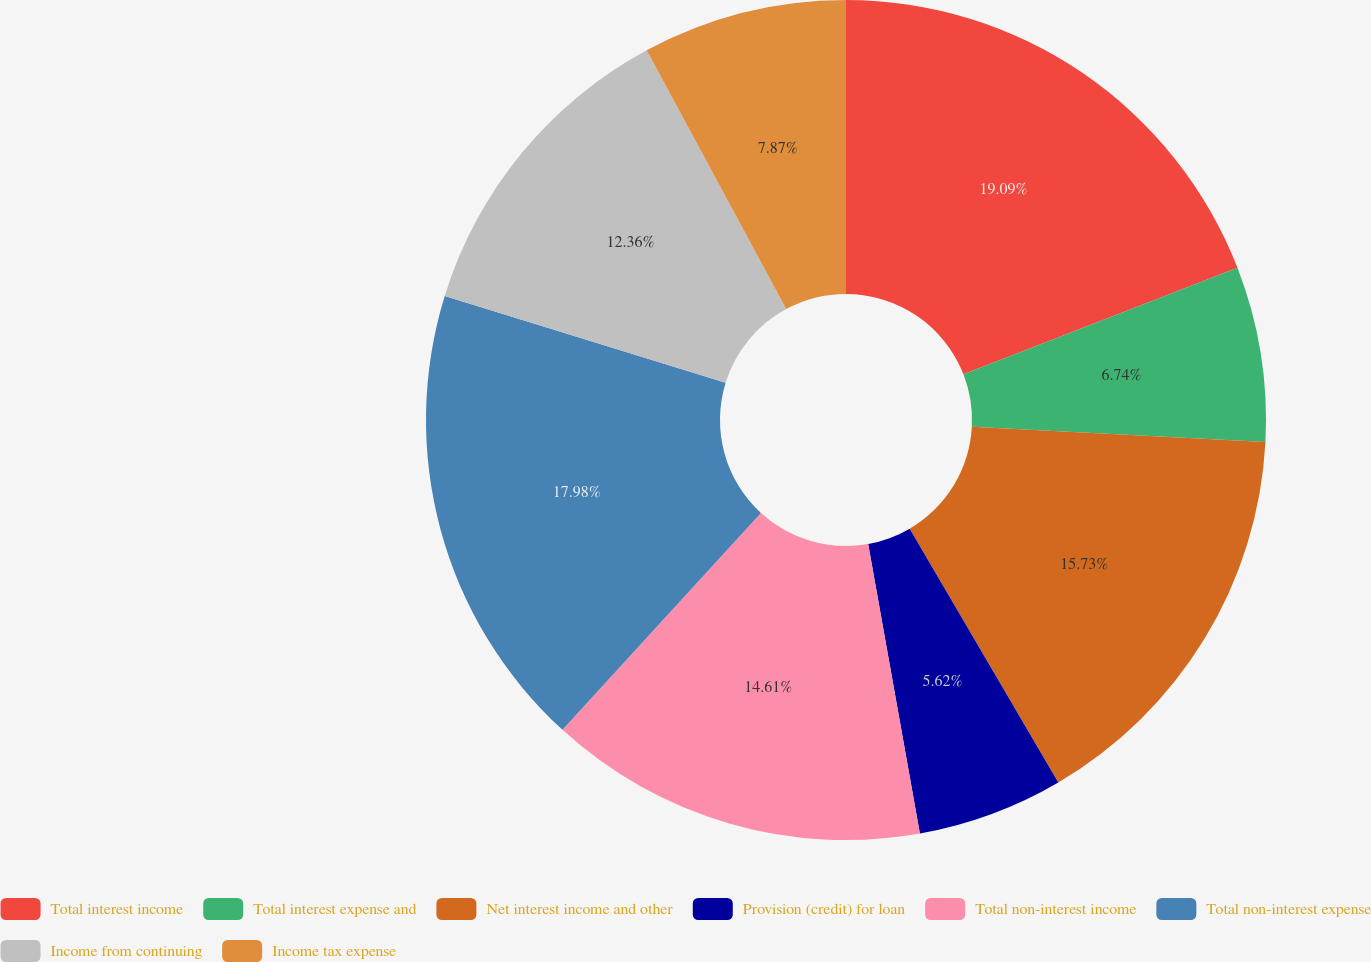Convert chart to OTSL. <chart><loc_0><loc_0><loc_500><loc_500><pie_chart><fcel>Total interest income<fcel>Total interest expense and<fcel>Net interest income and other<fcel>Provision (credit) for loan<fcel>Total non-interest income<fcel>Total non-interest expense<fcel>Income from continuing<fcel>Income tax expense<nl><fcel>19.1%<fcel>6.74%<fcel>15.73%<fcel>5.62%<fcel>14.61%<fcel>17.98%<fcel>12.36%<fcel>7.87%<nl></chart> 